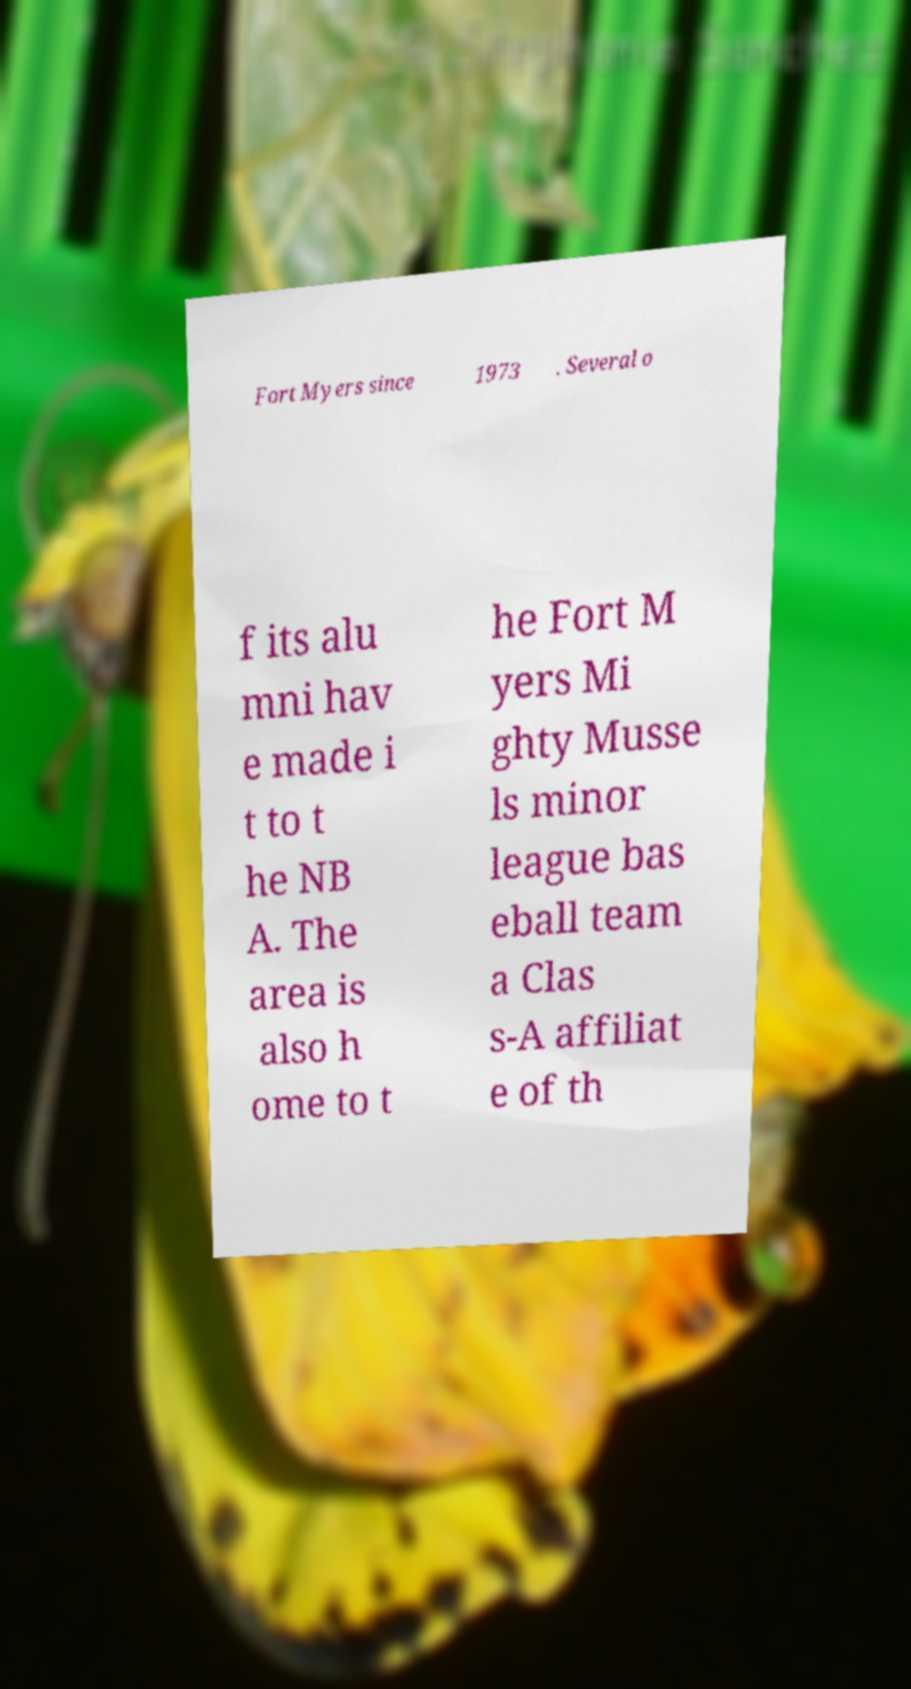Could you assist in decoding the text presented in this image and type it out clearly? Fort Myers since 1973 . Several o f its alu mni hav e made i t to t he NB A. The area is also h ome to t he Fort M yers Mi ghty Musse ls minor league bas eball team a Clas s-A affiliat e of th 